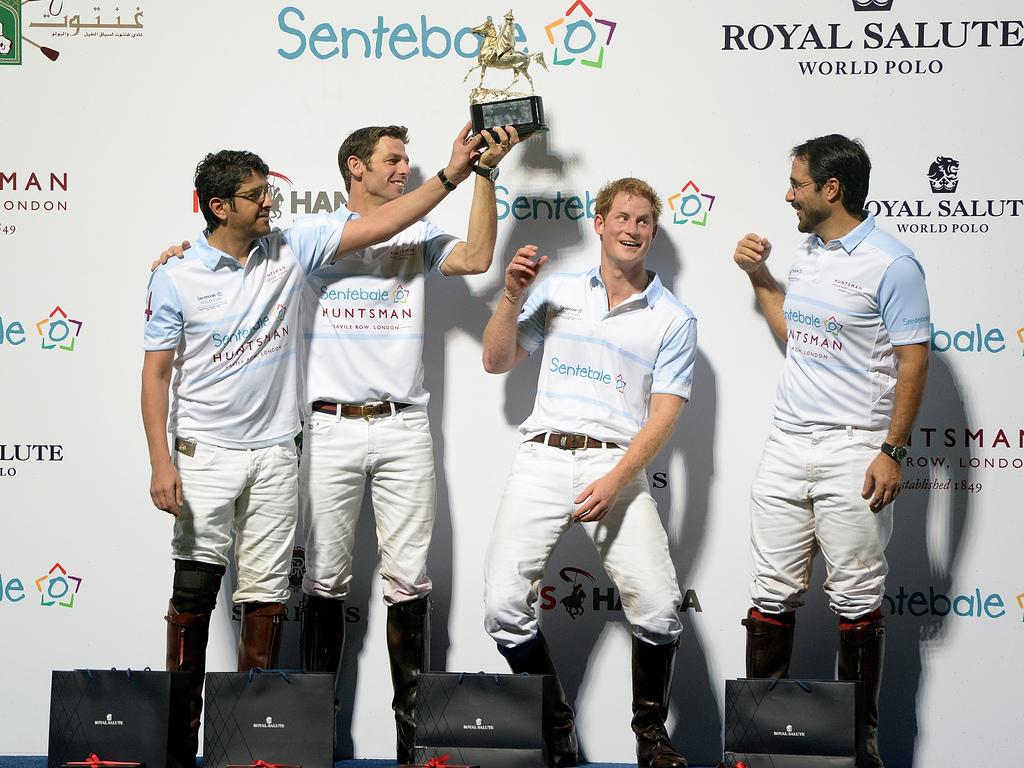What is one of the sponsers listed?
Your answer should be compact. Royal salute. 